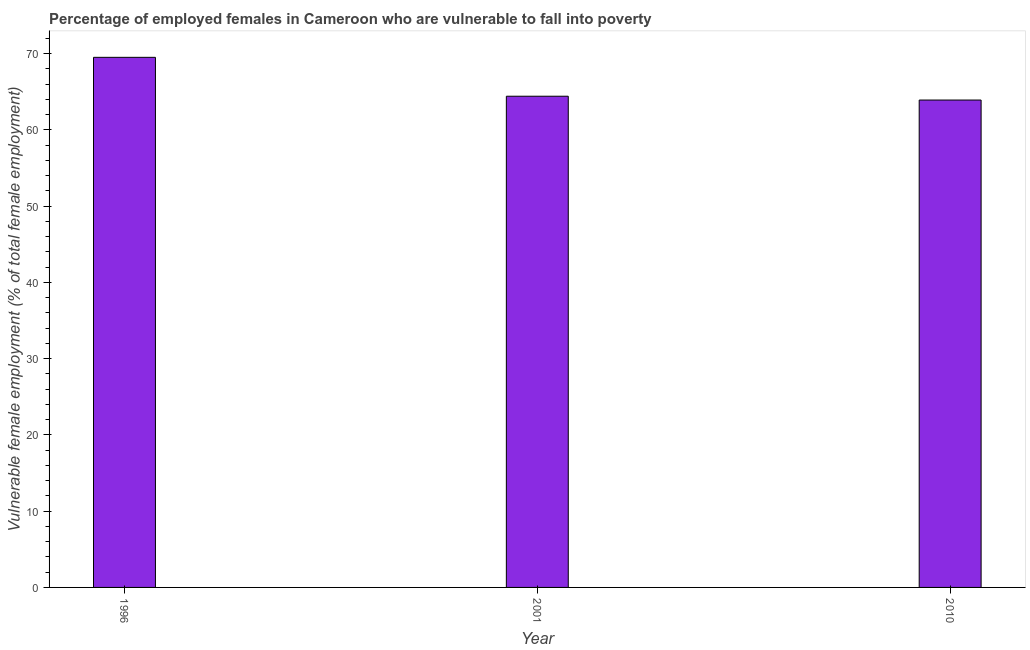Does the graph contain grids?
Offer a very short reply. No. What is the title of the graph?
Provide a succinct answer. Percentage of employed females in Cameroon who are vulnerable to fall into poverty. What is the label or title of the X-axis?
Provide a short and direct response. Year. What is the label or title of the Y-axis?
Give a very brief answer. Vulnerable female employment (% of total female employment). What is the percentage of employed females who are vulnerable to fall into poverty in 2010?
Give a very brief answer. 63.9. Across all years, what is the maximum percentage of employed females who are vulnerable to fall into poverty?
Your answer should be compact. 69.5. Across all years, what is the minimum percentage of employed females who are vulnerable to fall into poverty?
Provide a short and direct response. 63.9. In which year was the percentage of employed females who are vulnerable to fall into poverty maximum?
Your answer should be very brief. 1996. What is the sum of the percentage of employed females who are vulnerable to fall into poverty?
Give a very brief answer. 197.8. What is the average percentage of employed females who are vulnerable to fall into poverty per year?
Make the answer very short. 65.93. What is the median percentage of employed females who are vulnerable to fall into poverty?
Provide a succinct answer. 64.4. Do a majority of the years between 2010 and 1996 (inclusive) have percentage of employed females who are vulnerable to fall into poverty greater than 38 %?
Your answer should be compact. Yes. What is the ratio of the percentage of employed females who are vulnerable to fall into poverty in 1996 to that in 2010?
Ensure brevity in your answer.  1.09. Is the difference between the percentage of employed females who are vulnerable to fall into poverty in 2001 and 2010 greater than the difference between any two years?
Ensure brevity in your answer.  No. Is the sum of the percentage of employed females who are vulnerable to fall into poverty in 1996 and 2001 greater than the maximum percentage of employed females who are vulnerable to fall into poverty across all years?
Keep it short and to the point. Yes. Are all the bars in the graph horizontal?
Make the answer very short. No. Are the values on the major ticks of Y-axis written in scientific E-notation?
Your answer should be compact. No. What is the Vulnerable female employment (% of total female employment) of 1996?
Keep it short and to the point. 69.5. What is the Vulnerable female employment (% of total female employment) of 2001?
Provide a short and direct response. 64.4. What is the Vulnerable female employment (% of total female employment) in 2010?
Your answer should be very brief. 63.9. What is the difference between the Vulnerable female employment (% of total female employment) in 1996 and 2001?
Offer a terse response. 5.1. What is the difference between the Vulnerable female employment (% of total female employment) in 2001 and 2010?
Your answer should be compact. 0.5. What is the ratio of the Vulnerable female employment (% of total female employment) in 1996 to that in 2001?
Make the answer very short. 1.08. What is the ratio of the Vulnerable female employment (% of total female employment) in 1996 to that in 2010?
Your answer should be compact. 1.09. 